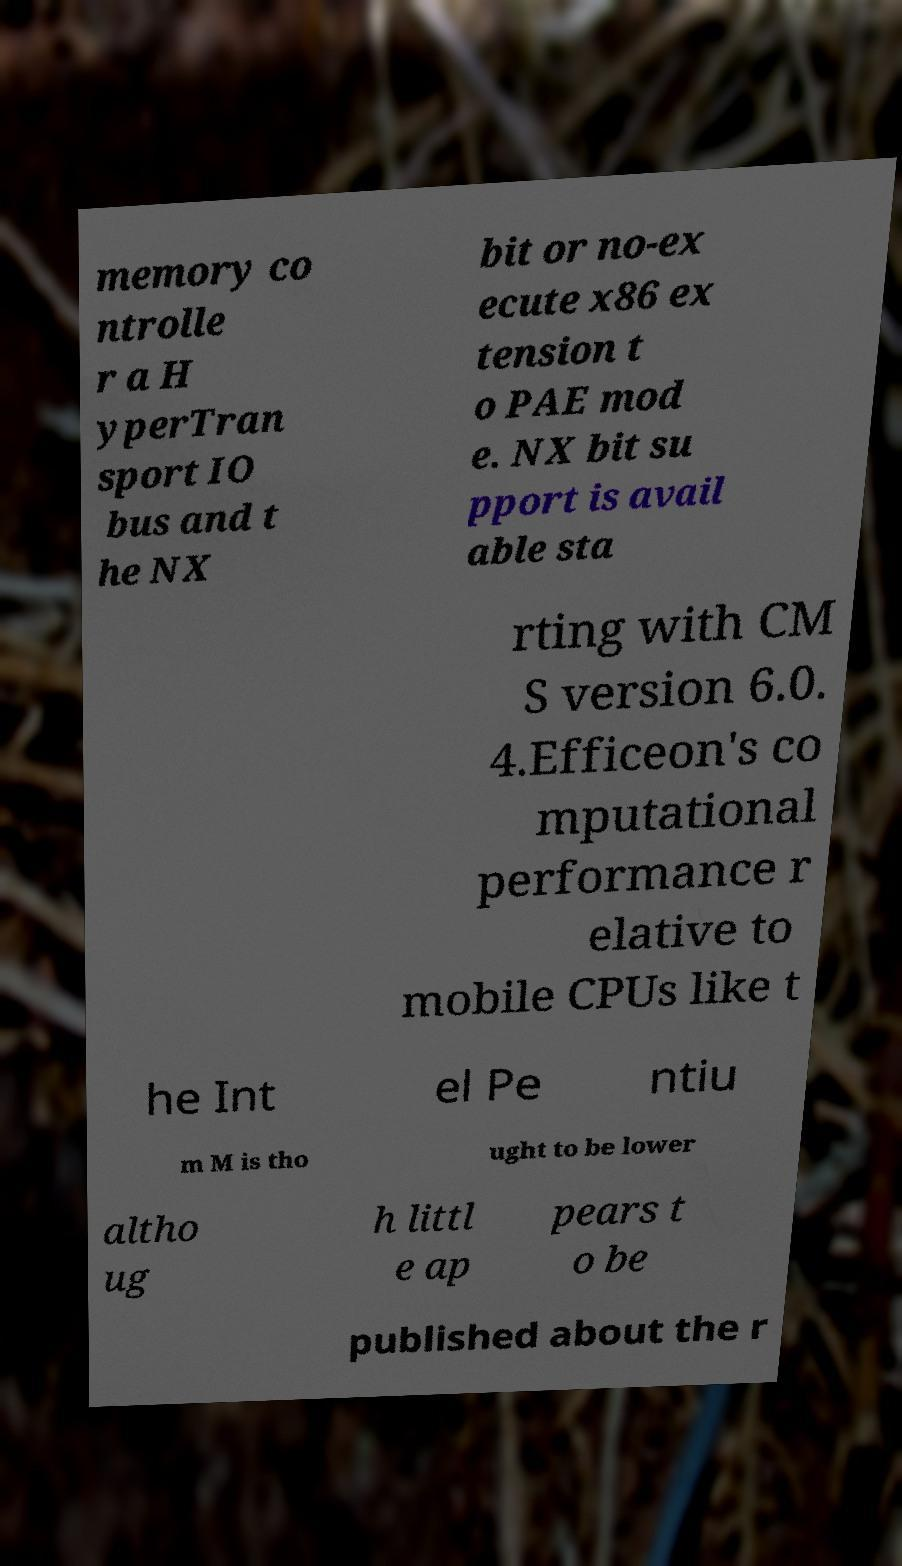Could you extract and type out the text from this image? memory co ntrolle r a H yperTran sport IO bus and t he NX bit or no-ex ecute x86 ex tension t o PAE mod e. NX bit su pport is avail able sta rting with CM S version 6.0. 4.Efficeon's co mputational performance r elative to mobile CPUs like t he Int el Pe ntiu m M is tho ught to be lower altho ug h littl e ap pears t o be published about the r 